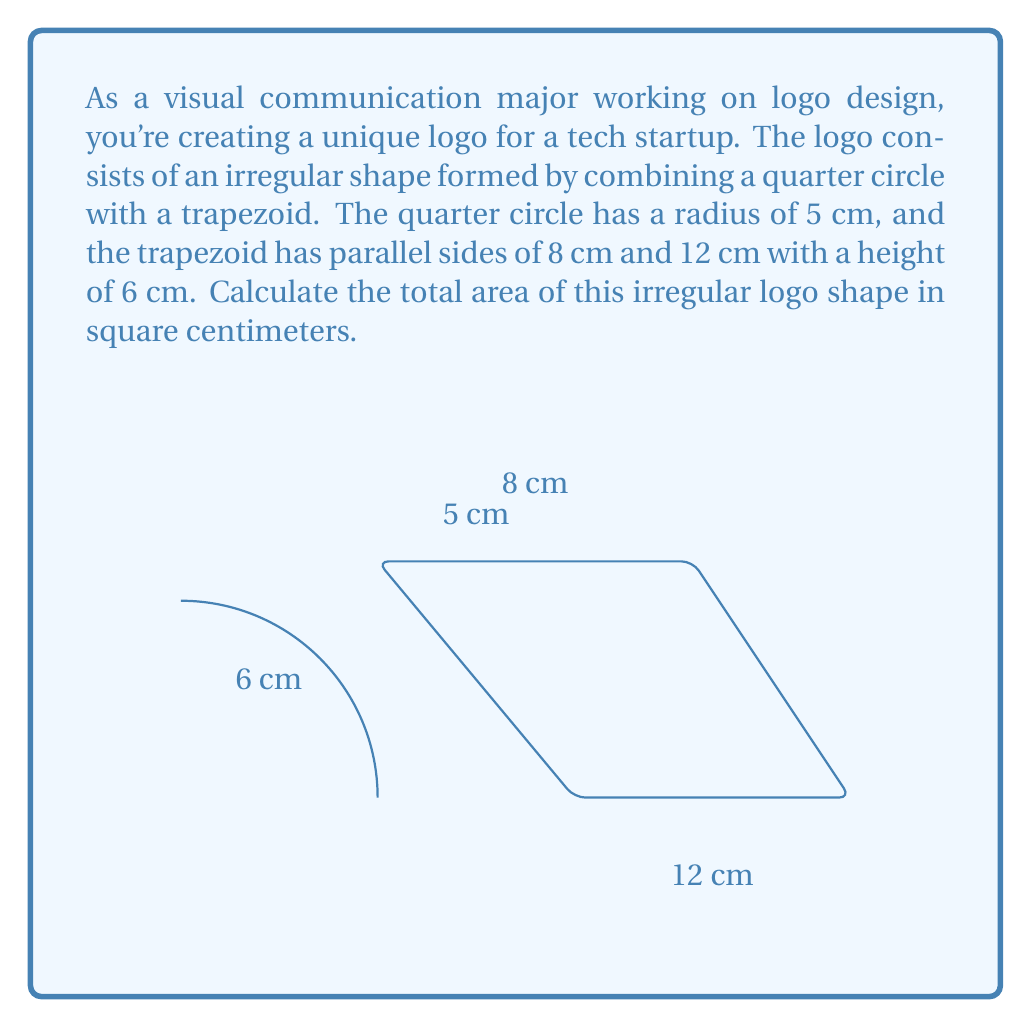What is the answer to this math problem? To solve this problem, we need to calculate the areas of the quarter circle and the trapezoid separately, then add them together.

1. Area of the quarter circle:
   The area of a full circle is $\pi r^2$, so the area of a quarter circle is $\frac{1}{4} \pi r^2$.
   $$A_{quarter} = \frac{1}{4} \pi (5\text{ cm})^2 = \frac{25\pi}{4} \text{ cm}^2$$

2. Area of the trapezoid:
   The formula for the area of a trapezoid is $A = \frac{1}{2}(b_1 + b_2)h$, where $b_1$ and $b_2$ are the parallel sides and $h$ is the height.
   $$A_{trapezoid} = \frac{1}{2}(8\text{ cm} + 12\text{ cm}) \times 6\text{ cm} = 60 \text{ cm}^2$$

3. Total area:
   The total area is the sum of the areas of the quarter circle and the trapezoid.
   $$A_{total} = A_{quarter} + A_{trapezoid} = \frac{25\pi}{4} \text{ cm}^2 + 60 \text{ cm}^2$$

4. Simplify:
   $$A_{total} = \frac{25\pi}{4} + 60 \text{ cm}^2 = (19.6349... + 60) \text{ cm}^2 = 79.6349... \text{ cm}^2$$

Rounding to two decimal places for practical use in design, we get 79.63 cm².
Answer: The total area of the irregular logo shape is approximately 79.63 cm². 